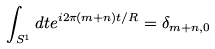<formula> <loc_0><loc_0><loc_500><loc_500>\int _ { S ^ { 1 } } d t e ^ { i 2 \pi ( m + n ) t / R } = \delta _ { m + n , 0 }</formula> 